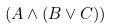<formula> <loc_0><loc_0><loc_500><loc_500>( A \wedge ( B \vee C ) )</formula> 